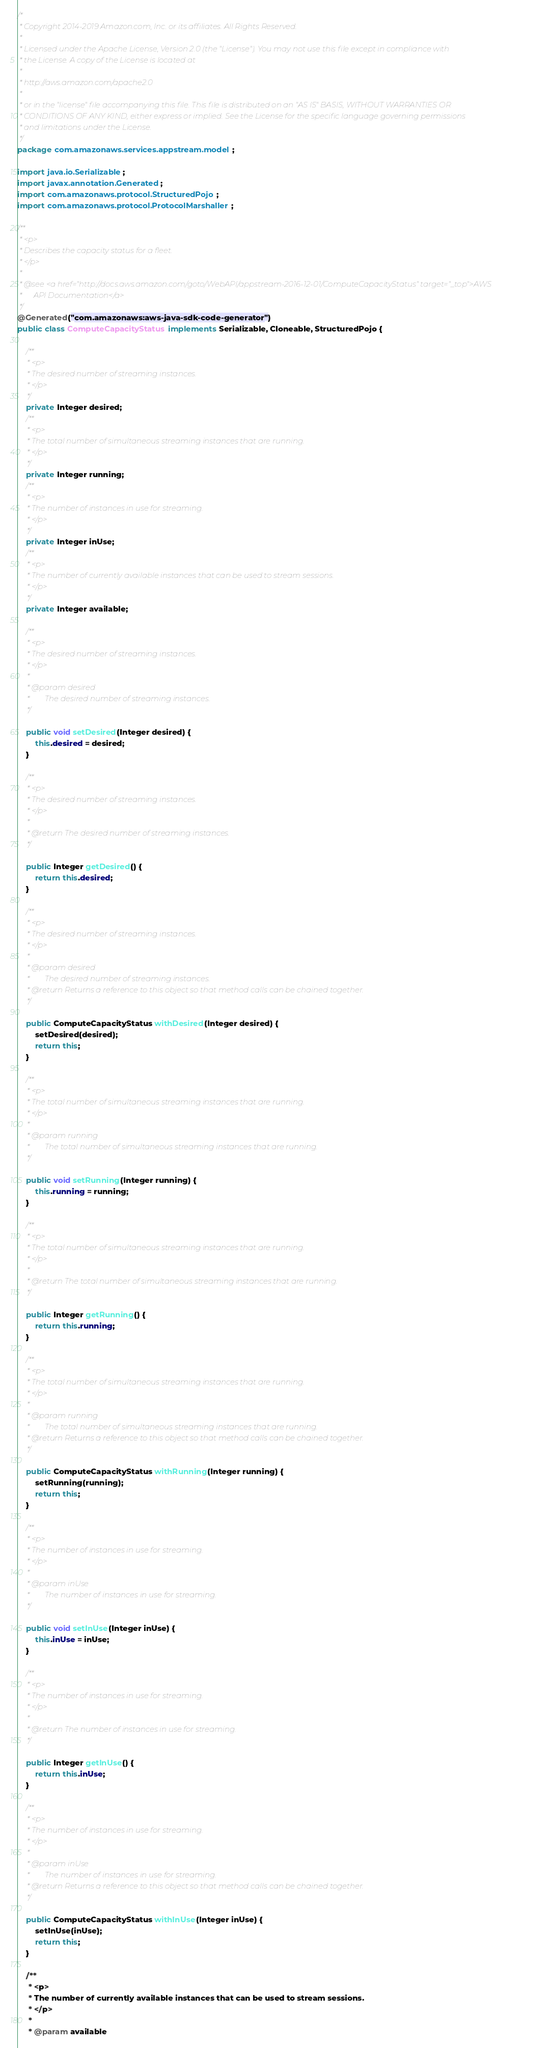Convert code to text. <code><loc_0><loc_0><loc_500><loc_500><_Java_>/*
 * Copyright 2014-2019 Amazon.com, Inc. or its affiliates. All Rights Reserved.
 * 
 * Licensed under the Apache License, Version 2.0 (the "License"). You may not use this file except in compliance with
 * the License. A copy of the License is located at
 * 
 * http://aws.amazon.com/apache2.0
 * 
 * or in the "license" file accompanying this file. This file is distributed on an "AS IS" BASIS, WITHOUT WARRANTIES OR
 * CONDITIONS OF ANY KIND, either express or implied. See the License for the specific language governing permissions
 * and limitations under the License.
 */
package com.amazonaws.services.appstream.model;

import java.io.Serializable;
import javax.annotation.Generated;
import com.amazonaws.protocol.StructuredPojo;
import com.amazonaws.protocol.ProtocolMarshaller;

/**
 * <p>
 * Describes the capacity status for a fleet.
 * </p>
 * 
 * @see <a href="http://docs.aws.amazon.com/goto/WebAPI/appstream-2016-12-01/ComputeCapacityStatus" target="_top">AWS
 *      API Documentation</a>
 */
@Generated("com.amazonaws:aws-java-sdk-code-generator")
public class ComputeCapacityStatus implements Serializable, Cloneable, StructuredPojo {

    /**
     * <p>
     * The desired number of streaming instances.
     * </p>
     */
    private Integer desired;
    /**
     * <p>
     * The total number of simultaneous streaming instances that are running.
     * </p>
     */
    private Integer running;
    /**
     * <p>
     * The number of instances in use for streaming.
     * </p>
     */
    private Integer inUse;
    /**
     * <p>
     * The number of currently available instances that can be used to stream sessions.
     * </p>
     */
    private Integer available;

    /**
     * <p>
     * The desired number of streaming instances.
     * </p>
     * 
     * @param desired
     *        The desired number of streaming instances.
     */

    public void setDesired(Integer desired) {
        this.desired = desired;
    }

    /**
     * <p>
     * The desired number of streaming instances.
     * </p>
     * 
     * @return The desired number of streaming instances.
     */

    public Integer getDesired() {
        return this.desired;
    }

    /**
     * <p>
     * The desired number of streaming instances.
     * </p>
     * 
     * @param desired
     *        The desired number of streaming instances.
     * @return Returns a reference to this object so that method calls can be chained together.
     */

    public ComputeCapacityStatus withDesired(Integer desired) {
        setDesired(desired);
        return this;
    }

    /**
     * <p>
     * The total number of simultaneous streaming instances that are running.
     * </p>
     * 
     * @param running
     *        The total number of simultaneous streaming instances that are running.
     */

    public void setRunning(Integer running) {
        this.running = running;
    }

    /**
     * <p>
     * The total number of simultaneous streaming instances that are running.
     * </p>
     * 
     * @return The total number of simultaneous streaming instances that are running.
     */

    public Integer getRunning() {
        return this.running;
    }

    /**
     * <p>
     * The total number of simultaneous streaming instances that are running.
     * </p>
     * 
     * @param running
     *        The total number of simultaneous streaming instances that are running.
     * @return Returns a reference to this object so that method calls can be chained together.
     */

    public ComputeCapacityStatus withRunning(Integer running) {
        setRunning(running);
        return this;
    }

    /**
     * <p>
     * The number of instances in use for streaming.
     * </p>
     * 
     * @param inUse
     *        The number of instances in use for streaming.
     */

    public void setInUse(Integer inUse) {
        this.inUse = inUse;
    }

    /**
     * <p>
     * The number of instances in use for streaming.
     * </p>
     * 
     * @return The number of instances in use for streaming.
     */

    public Integer getInUse() {
        return this.inUse;
    }

    /**
     * <p>
     * The number of instances in use for streaming.
     * </p>
     * 
     * @param inUse
     *        The number of instances in use for streaming.
     * @return Returns a reference to this object so that method calls can be chained together.
     */

    public ComputeCapacityStatus withInUse(Integer inUse) {
        setInUse(inUse);
        return this;
    }

    /**
     * <p>
     * The number of currently available instances that can be used to stream sessions.
     * </p>
     * 
     * @param available</code> 